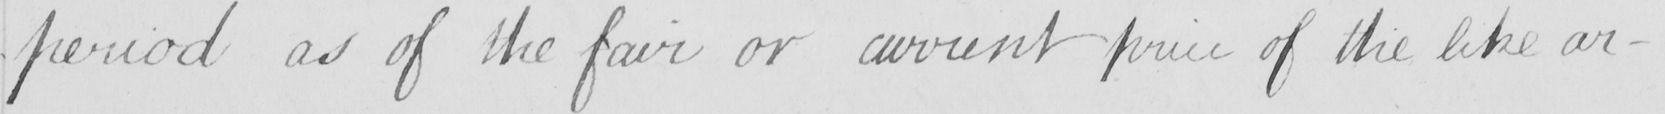Can you read and transcribe this handwriting? period as of the fair or current price of the like ar- 